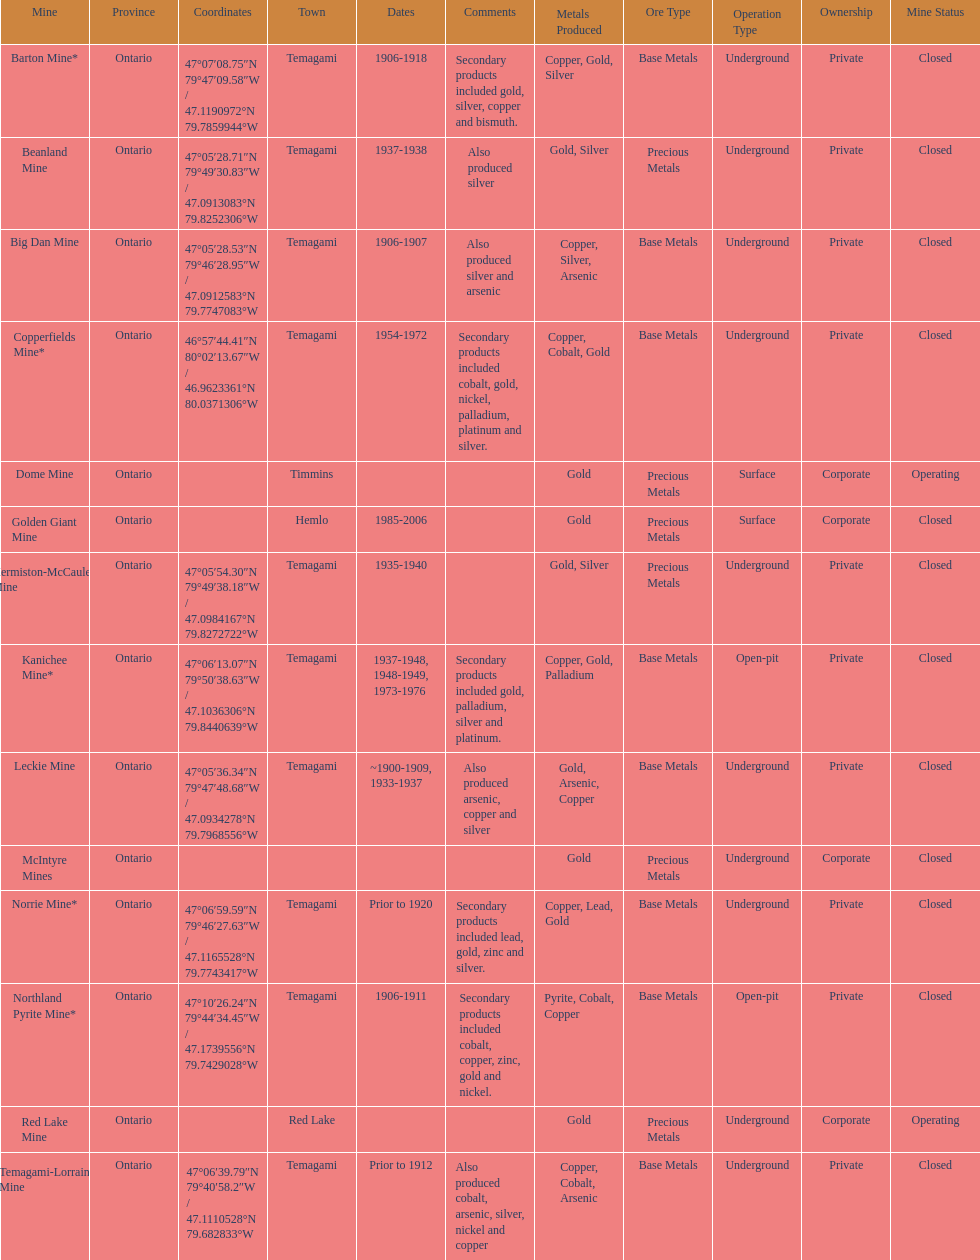What mine is in the town of timmins? Dome Mine. Can you give me this table as a dict? {'header': ['Mine', 'Province', 'Coordinates', 'Town', 'Dates', 'Comments', 'Metals Produced', 'Ore Type', 'Operation Type', 'Ownership', 'Mine Status'], 'rows': [['Barton Mine*', 'Ontario', '47°07′08.75″N 79°47′09.58″W\ufeff / \ufeff47.1190972°N 79.7859944°W', 'Temagami', '1906-1918', 'Secondary products included gold, silver, copper and bismuth.', 'Copper, Gold, Silver', 'Base Metals', 'Underground', 'Private', 'Closed'], ['Beanland Mine', 'Ontario', '47°05′28.71″N 79°49′30.83″W\ufeff / \ufeff47.0913083°N 79.8252306°W', 'Temagami', '1937-1938', 'Also produced silver', 'Gold, Silver', 'Precious Metals', 'Underground', 'Private', 'Closed'], ['Big Dan Mine', 'Ontario', '47°05′28.53″N 79°46′28.95″W\ufeff / \ufeff47.0912583°N 79.7747083°W', 'Temagami', '1906-1907', 'Also produced silver and arsenic', 'Copper, Silver, Arsenic', 'Base Metals', 'Underground', 'Private', 'Closed'], ['Copperfields Mine*', 'Ontario', '46°57′44.41″N 80°02′13.67″W\ufeff / \ufeff46.9623361°N 80.0371306°W', 'Temagami', '1954-1972', 'Secondary products included cobalt, gold, nickel, palladium, platinum and silver.', 'Copper, Cobalt, Gold', 'Base Metals', 'Underground', 'Private', 'Closed'], ['Dome Mine', 'Ontario', '', 'Timmins', '', '', 'Gold', 'Precious Metals', 'Surface', 'Corporate', 'Operating'], ['Golden Giant Mine', 'Ontario', '', 'Hemlo', '1985-2006', '', 'Gold', 'Precious Metals', 'Surface', 'Corporate', 'Closed'], ['Hermiston-McCauley Mine', 'Ontario', '47°05′54.30″N 79°49′38.18″W\ufeff / \ufeff47.0984167°N 79.8272722°W', 'Temagami', '1935-1940', '', 'Gold, Silver', 'Precious Metals', 'Underground', 'Private', 'Closed'], ['Kanichee Mine*', 'Ontario', '47°06′13.07″N 79°50′38.63″W\ufeff / \ufeff47.1036306°N 79.8440639°W', 'Temagami', '1937-1948, 1948-1949, 1973-1976', 'Secondary products included gold, palladium, silver and platinum.', 'Copper, Gold, Palladium', 'Base Metals', 'Open-pit', 'Private', 'Closed'], ['Leckie Mine', 'Ontario', '47°05′36.34″N 79°47′48.68″W\ufeff / \ufeff47.0934278°N 79.7968556°W', 'Temagami', '~1900-1909, 1933-1937', 'Also produced arsenic, copper and silver', 'Gold, Arsenic, Copper', 'Base Metals', 'Underground', 'Private', 'Closed'], ['McIntyre Mines', 'Ontario', '', '', '', '', 'Gold', 'Precious Metals', 'Underground', 'Corporate', 'Closed'], ['Norrie Mine*', 'Ontario', '47°06′59.59″N 79°46′27.63″W\ufeff / \ufeff47.1165528°N 79.7743417°W', 'Temagami', 'Prior to 1920', 'Secondary products included lead, gold, zinc and silver.', 'Copper, Lead, Gold', 'Base Metals', 'Underground', 'Private', 'Closed'], ['Northland Pyrite Mine*', 'Ontario', '47°10′26.24″N 79°44′34.45″W\ufeff / \ufeff47.1739556°N 79.7429028°W', 'Temagami', '1906-1911', 'Secondary products included cobalt, copper, zinc, gold and nickel.', 'Pyrite, Cobalt, Copper', 'Base Metals', 'Open-pit', 'Private', 'Closed'], ['Red Lake Mine', 'Ontario', '', 'Red Lake', '', '', 'Gold', 'Precious Metals', 'Underground', 'Corporate', 'Operating'], ['Temagami-Lorrain Mine', 'Ontario', '47°06′39.79″N 79°40′58.2″W\ufeff / \ufeff47.1110528°N 79.682833°W', 'Temagami', 'Prior to 1912', 'Also produced cobalt, arsenic, silver, nickel and copper', 'Copper, Cobalt, Arsenic', 'Base Metals', 'Underground', 'Private', 'Closed']]} 